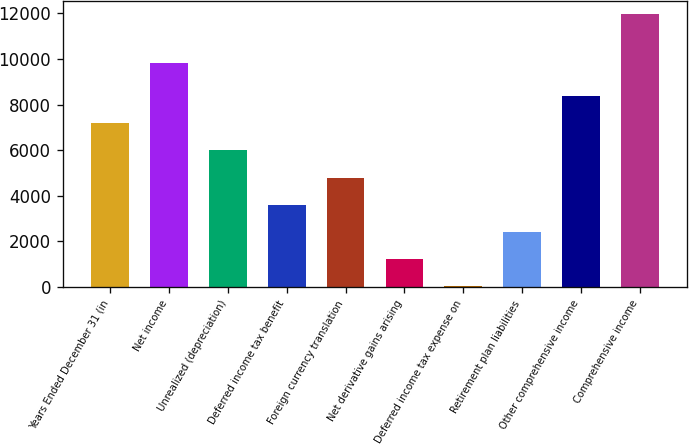Convert chart. <chart><loc_0><loc_0><loc_500><loc_500><bar_chart><fcel>Years Ended December 31 (in<fcel>Net income<fcel>Unrealized (depreciation)<fcel>Deferred income tax benefit<fcel>Foreign currency translation<fcel>Net derivative gains arising<fcel>Deferred income tax expense on<fcel>Retirement plan liabilities<fcel>Other comprehensive income<fcel>Comprehensive income<nl><fcel>7180.8<fcel>9839<fcel>5989.5<fcel>3606.9<fcel>4798.2<fcel>1224.3<fcel>33<fcel>2415.6<fcel>8372.1<fcel>11946<nl></chart> 